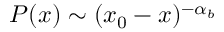<formula> <loc_0><loc_0><loc_500><loc_500>P ( x ) \sim ( x _ { 0 } - x ) ^ { - \alpha _ { b } }</formula> 